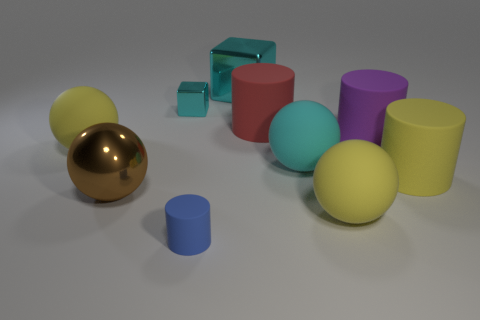Subtract all cylinders. How many objects are left? 6 Add 2 small metallic things. How many small metallic things are left? 3 Add 3 tiny metallic things. How many tiny metallic things exist? 4 Subtract 1 cyan spheres. How many objects are left? 9 Subtract all brown spheres. Subtract all metal objects. How many objects are left? 6 